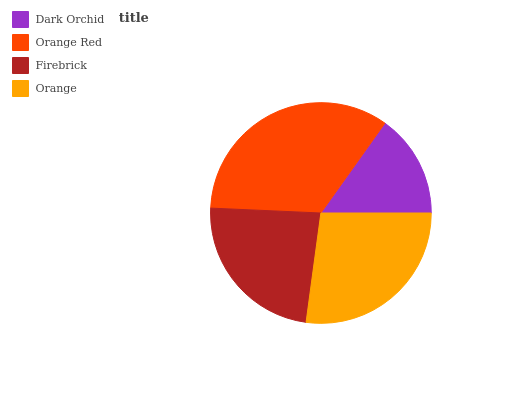Is Dark Orchid the minimum?
Answer yes or no. Yes. Is Orange Red the maximum?
Answer yes or no. Yes. Is Firebrick the minimum?
Answer yes or no. No. Is Firebrick the maximum?
Answer yes or no. No. Is Orange Red greater than Firebrick?
Answer yes or no. Yes. Is Firebrick less than Orange Red?
Answer yes or no. Yes. Is Firebrick greater than Orange Red?
Answer yes or no. No. Is Orange Red less than Firebrick?
Answer yes or no. No. Is Orange the high median?
Answer yes or no. Yes. Is Firebrick the low median?
Answer yes or no. Yes. Is Firebrick the high median?
Answer yes or no. No. Is Orange Red the low median?
Answer yes or no. No. 